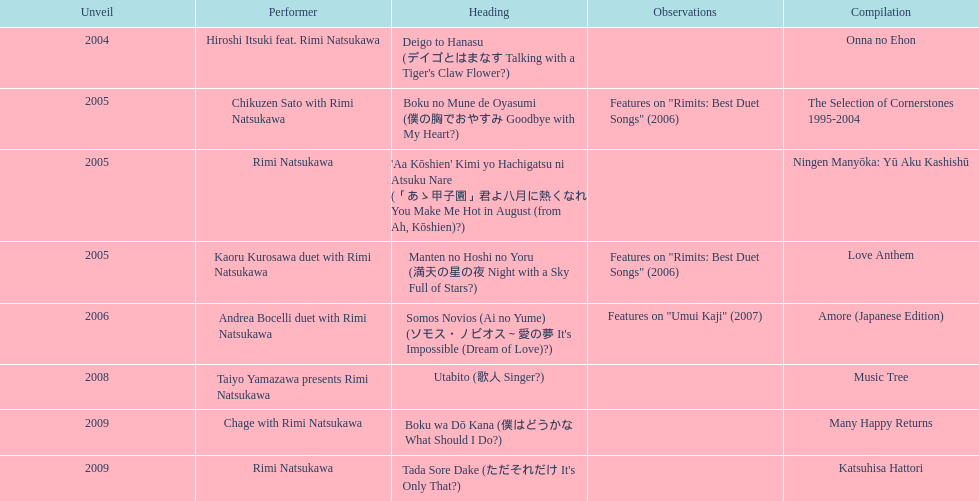How many titles have only one artist? 2. 